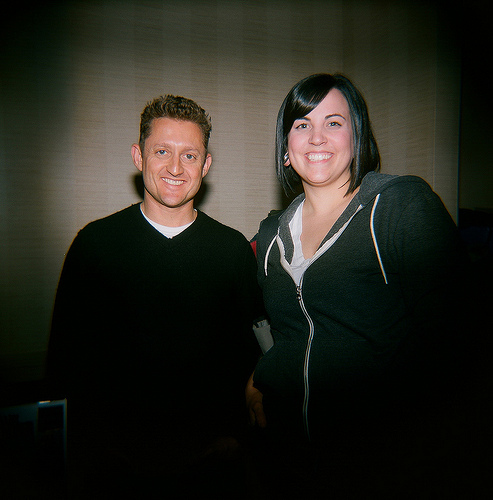<image>
Can you confirm if the woman is to the left of the man? Yes. From this viewpoint, the woman is positioned to the left side relative to the man. 